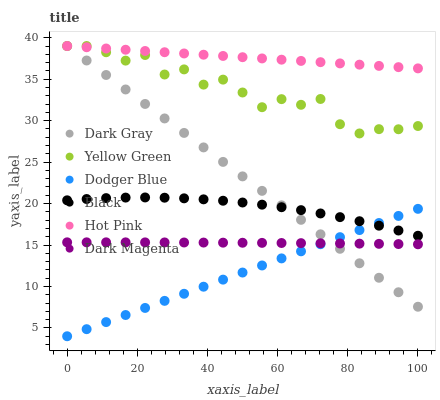Does Dodger Blue have the minimum area under the curve?
Answer yes or no. Yes. Does Hot Pink have the maximum area under the curve?
Answer yes or no. Yes. Does Dark Gray have the minimum area under the curve?
Answer yes or no. No. Does Dark Gray have the maximum area under the curve?
Answer yes or no. No. Is Hot Pink the smoothest?
Answer yes or no. Yes. Is Yellow Green the roughest?
Answer yes or no. Yes. Is Dark Gray the smoothest?
Answer yes or no. No. Is Dark Gray the roughest?
Answer yes or no. No. Does Dodger Blue have the lowest value?
Answer yes or no. Yes. Does Dark Gray have the lowest value?
Answer yes or no. No. Does Dark Gray have the highest value?
Answer yes or no. Yes. Does Black have the highest value?
Answer yes or no. No. Is Black less than Yellow Green?
Answer yes or no. Yes. Is Hot Pink greater than Dodger Blue?
Answer yes or no. Yes. Does Hot Pink intersect Dark Gray?
Answer yes or no. Yes. Is Hot Pink less than Dark Gray?
Answer yes or no. No. Is Hot Pink greater than Dark Gray?
Answer yes or no. No. Does Black intersect Yellow Green?
Answer yes or no. No. 